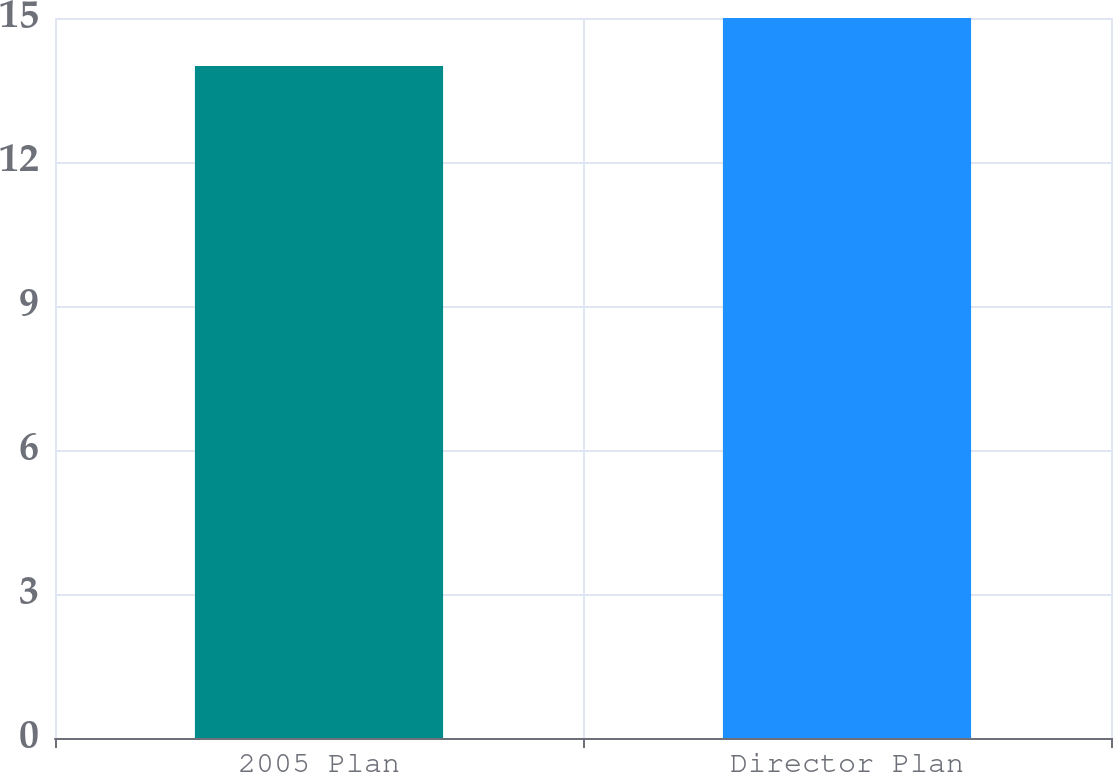<chart> <loc_0><loc_0><loc_500><loc_500><bar_chart><fcel>2005 Plan<fcel>Director Plan<nl><fcel>14<fcel>15<nl></chart> 